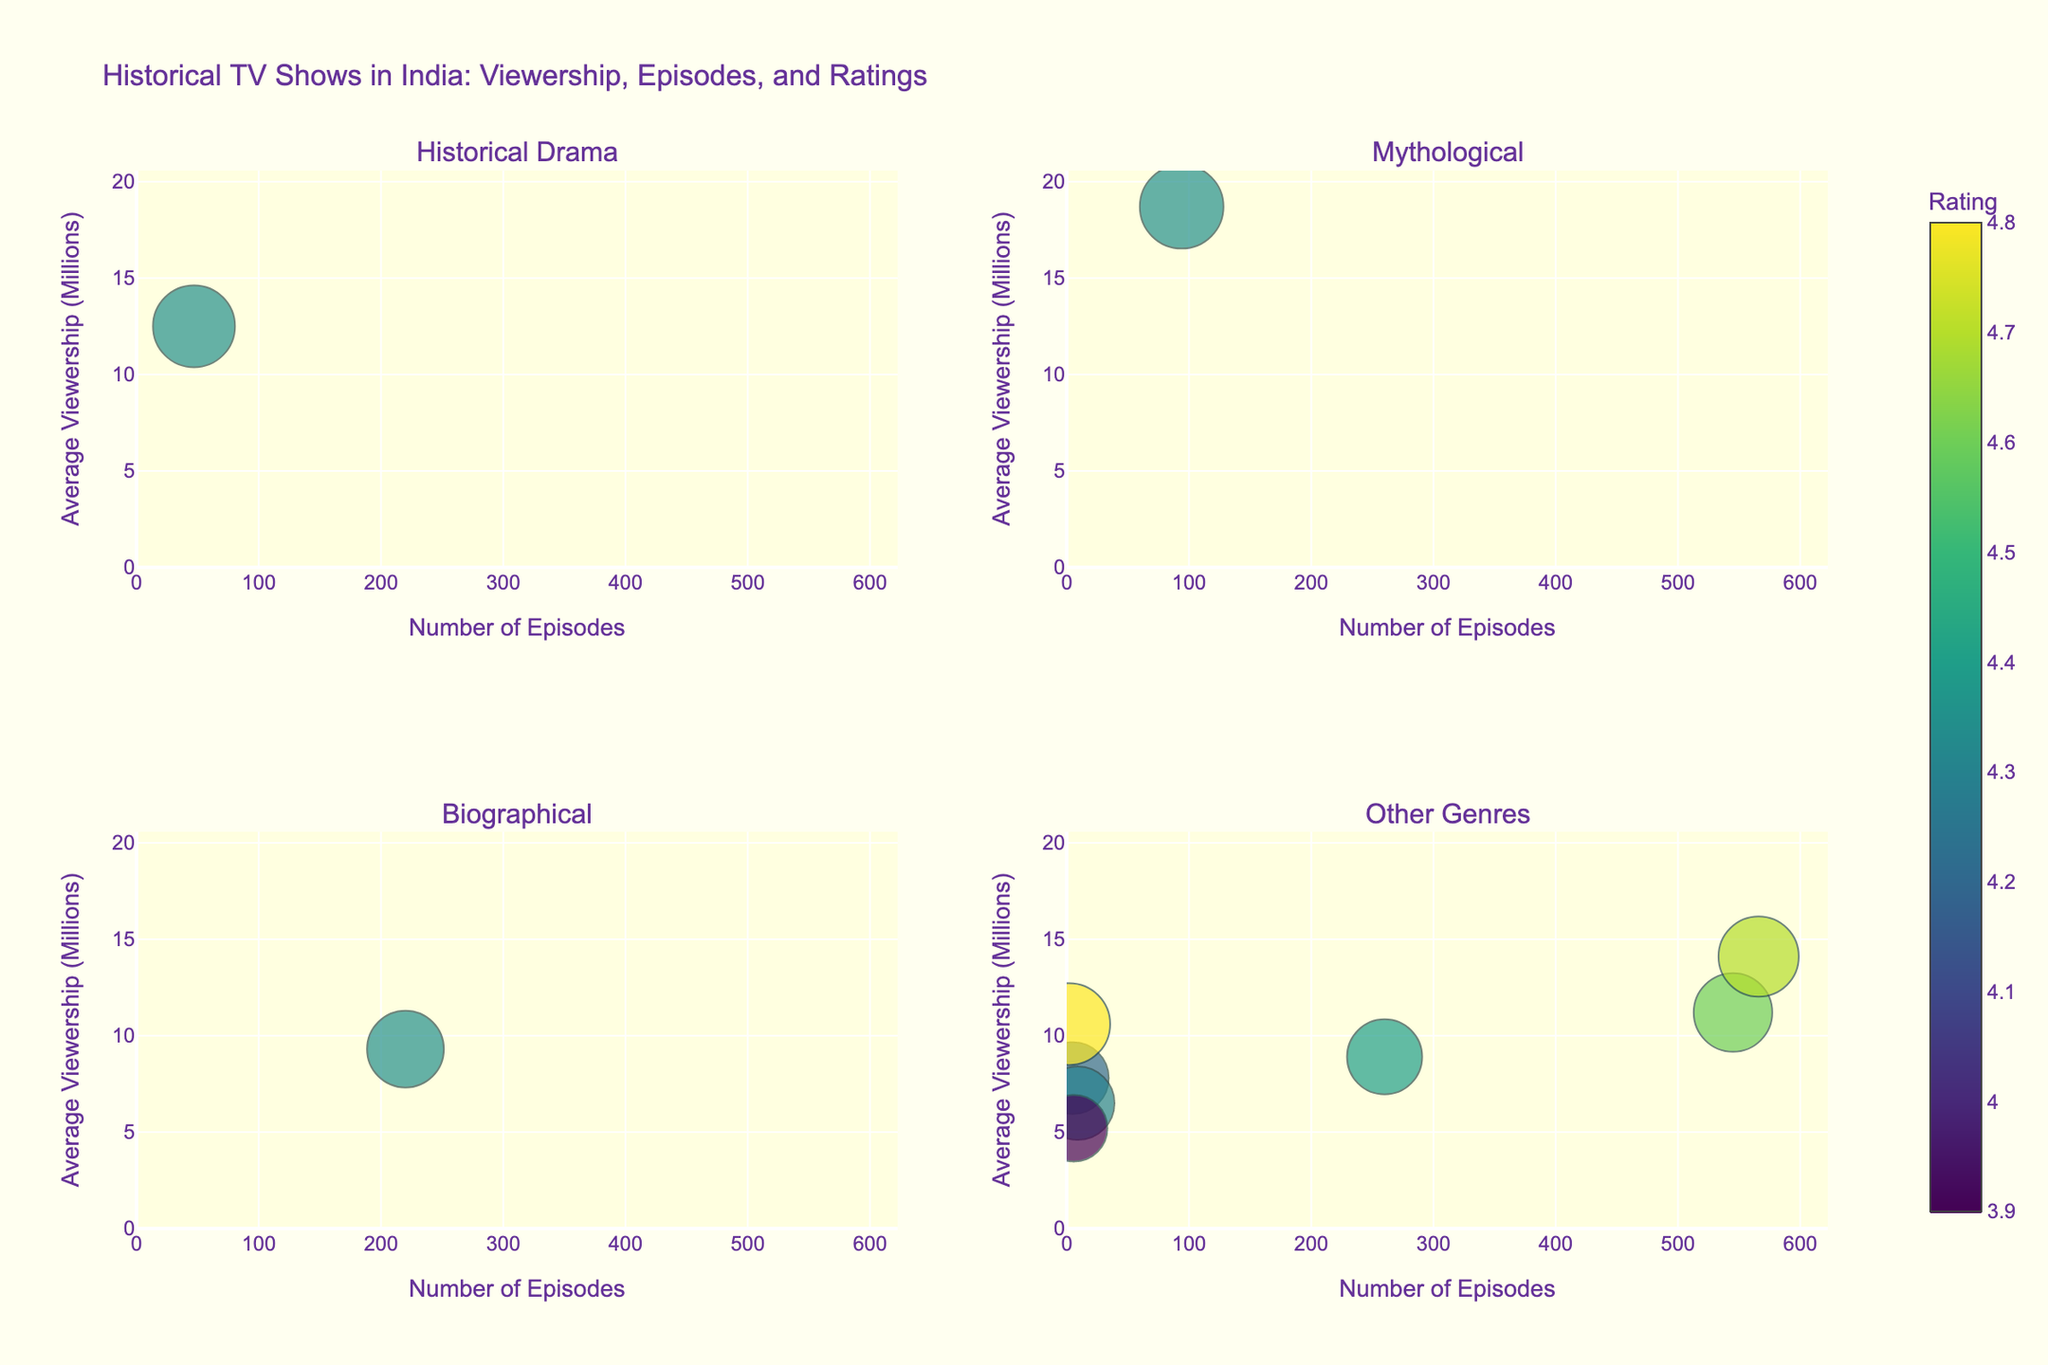How many shows from the Mythological genre are depicted in the figure? Count the number of bubbles in the subplot titled 'Mythological'. There is only one bubble corresponding to the Mythological show.
Answer: 1 Which show has the highest average viewership in the Biographical genre? Look at the second subplot titled 'Biographical'. The only bubble in this subplot represents 'Jhansi Ki Rani' with an average viewership of 9.3 million.
Answer: Jhansi Ki Rani What genre has the show with the smallest rating in the 'Other Genres' subplot? Refer to the fourth subplot titled 'Other Genres' and identify the bubble with the smallest size (rating is represented by the size of the bubble). 'Beecham House' has the smallest rating of 3.9 from the Colonial Era genre.
Answer: Colonial Era Which era has the highest average viewership across all shows? Compare the average viewership values from each subplot. 'Mahabharat' from the Epic Era has the highest viewership of 18.7 million.
Answer: Epic Era What is the relationship between the number of episodes and ratings among the shows in the 'Historical Drama' genre? Look at the first subplot titled 'Historical Drama'. 'Chanakya' is the single show here with 47 episodes and a rating of 4.8.
Answer: High rating, fewer episodes What's the average number of episodes for shows in the 'Other Genres' subplot? 'The Forgotten Army' has 5, 'Bose: Dead/Alive' has 9, 'Beecham House' has 6, 'Porus' has 260, and 'Chaar Sahibzaade' has 2. Sum these (5 + 9 + 6 + 260 + 2) = 282 and divide by 5 shows.
Answer: 56.4 episodes Which show in the other genres has the highest rating, and what is it? Refer to the fourth subplot titled 'Other Genres'. The largest bubble corresponds to the show with the highest rating. 'Chaar Sahibzaade' has the highest rating of 4.8.
Answer: Chaar Sahibzaade Is there a show with a higher rating but fewer episodes than 'Jodha Akbar' in the 'Other Genres' subplot? 'Jodha Akbar' has a rating of 4.7 and 566 episodes. Compare it to other bubbles within the fourth subplot. 'Chaar Sahibzaade' has a higher rating of 4.8 with only 2 episodes, fewer than 566.
Answer: Yes, 'Chaar Sahibzaade' 